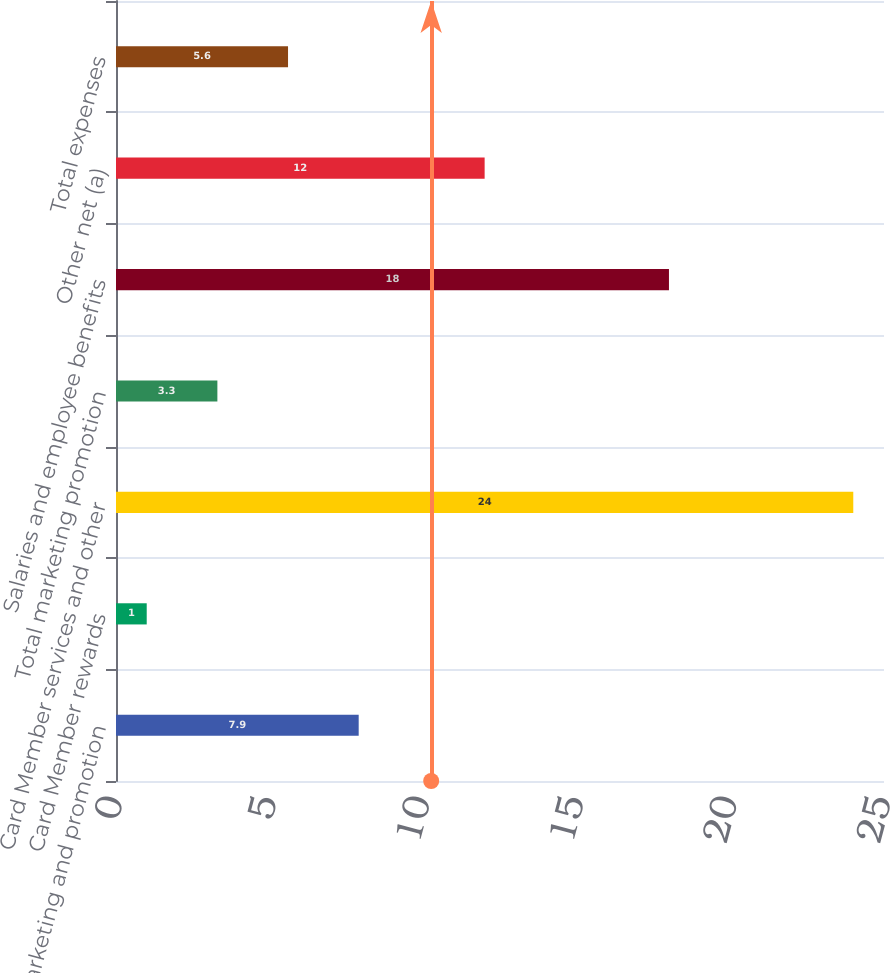Convert chart to OTSL. <chart><loc_0><loc_0><loc_500><loc_500><bar_chart><fcel>Marketing and promotion<fcel>Card Member rewards<fcel>Card Member services and other<fcel>Total marketing promotion<fcel>Salaries and employee benefits<fcel>Other net (a)<fcel>Total expenses<nl><fcel>7.9<fcel>1<fcel>24<fcel>3.3<fcel>18<fcel>12<fcel>5.6<nl></chart> 